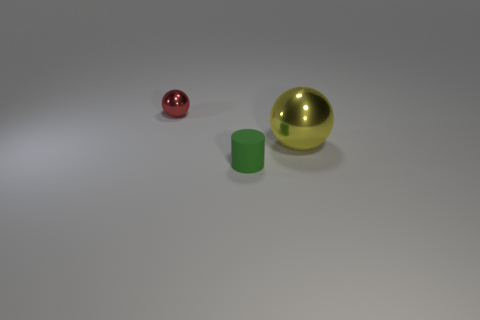Is there any other thing that is the same size as the yellow ball?
Give a very brief answer. No. Are there any other things that have the same shape as the red metallic object?
Provide a succinct answer. Yes. What number of objects are both in front of the small red metal object and behind the small green cylinder?
Provide a short and direct response. 1. What material is the small ball?
Keep it short and to the point. Metal. Are there the same number of tiny red things in front of the red object and large things?
Give a very brief answer. No. How many other things have the same shape as the tiny red metallic object?
Your answer should be very brief. 1. Is the yellow metallic thing the same shape as the red shiny object?
Your response must be concise. Yes. How many objects are either metallic objects that are left of the small green matte object or large green metal cylinders?
Offer a terse response. 1. What shape is the thing to the left of the small object that is in front of the sphere to the right of the green rubber object?
Provide a succinct answer. Sphere. There is a large object that is the same material as the red ball; what shape is it?
Make the answer very short. Sphere. 